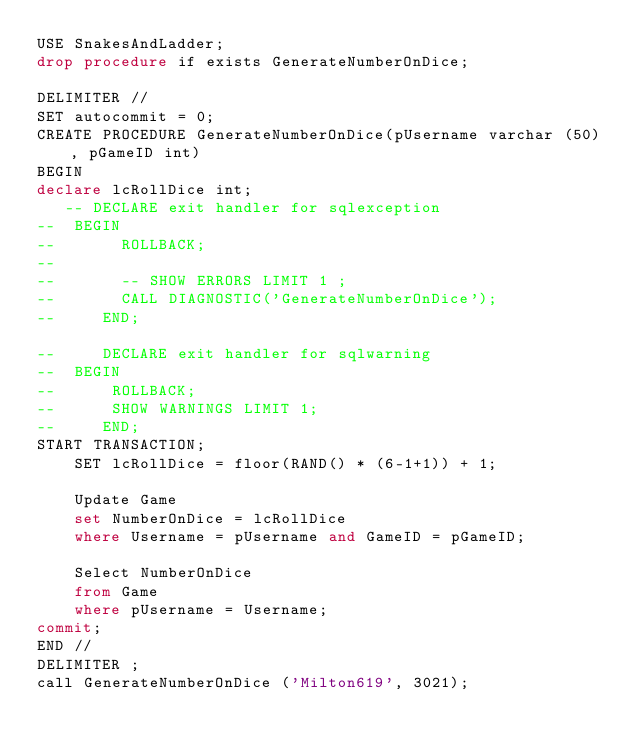Convert code to text. <code><loc_0><loc_0><loc_500><loc_500><_SQL_>USE SnakesAndLadder;
drop procedure if exists GenerateNumberOnDice;

DELIMITER //
SET autocommit = 0;
CREATE PROCEDURE GenerateNumberOnDice(pUsername varchar (50), pGameID int)
BEGIN
declare lcRollDice int;
   -- DECLARE exit handler for sqlexception
-- 	BEGIN
--       ROLLBACK;
--       
--       -- SHOW ERRORS LIMIT 1 ;
--       CALL DIAGNOSTIC('GenerateNumberOnDice');
--     END;

--     DECLARE exit handler for sqlwarning
-- 	BEGIN
--      ROLLBACK;
--      SHOW WARNINGS LIMIT 1;
--     END;
START TRANSACTION;
	SET lcRollDice = floor(RAND() * (6-1+1)) + 1; 
		
	Update Game
	set NumberOnDice = lcRollDice
	where Username = pUsername and GameID = pGameID;
			
	Select NumberOnDice
	from Game
	where pUsername = Username;
commit;
END //
DELIMITER ;
call GenerateNumberOnDice ('Milton619', 3021);

</code> 